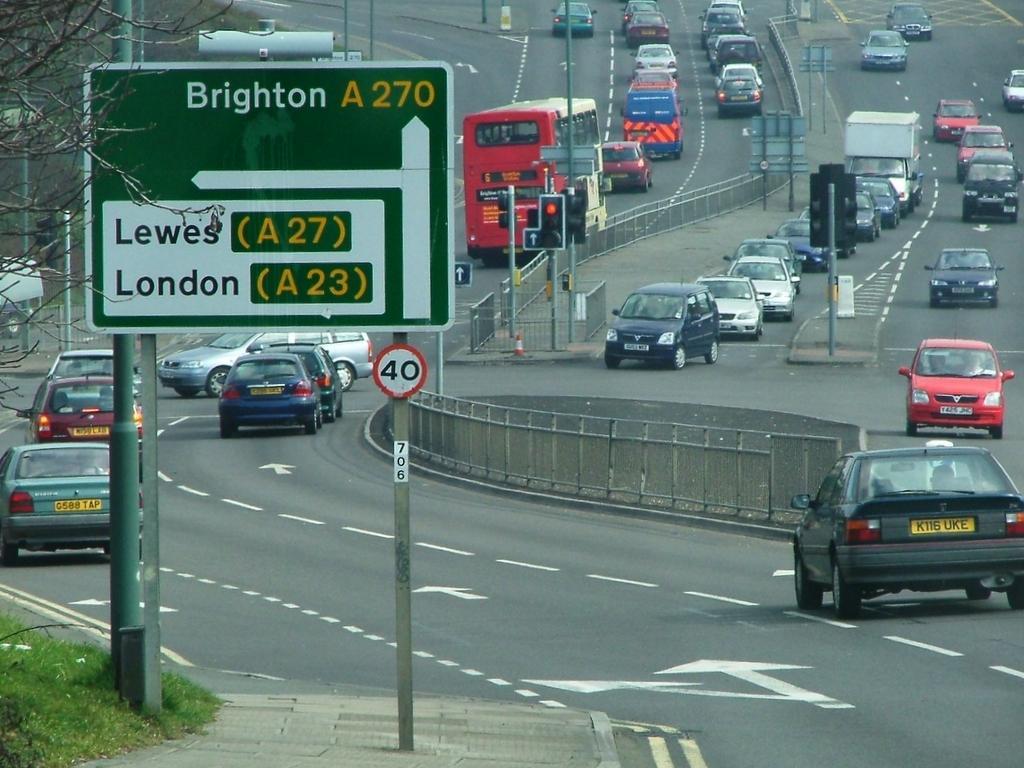Can you describe this image briefly? This image consists of fleets of vehicles on the road, fence, boards, grass, pillars, light poles, trees and stoppers. This image is taken may be during a day. 